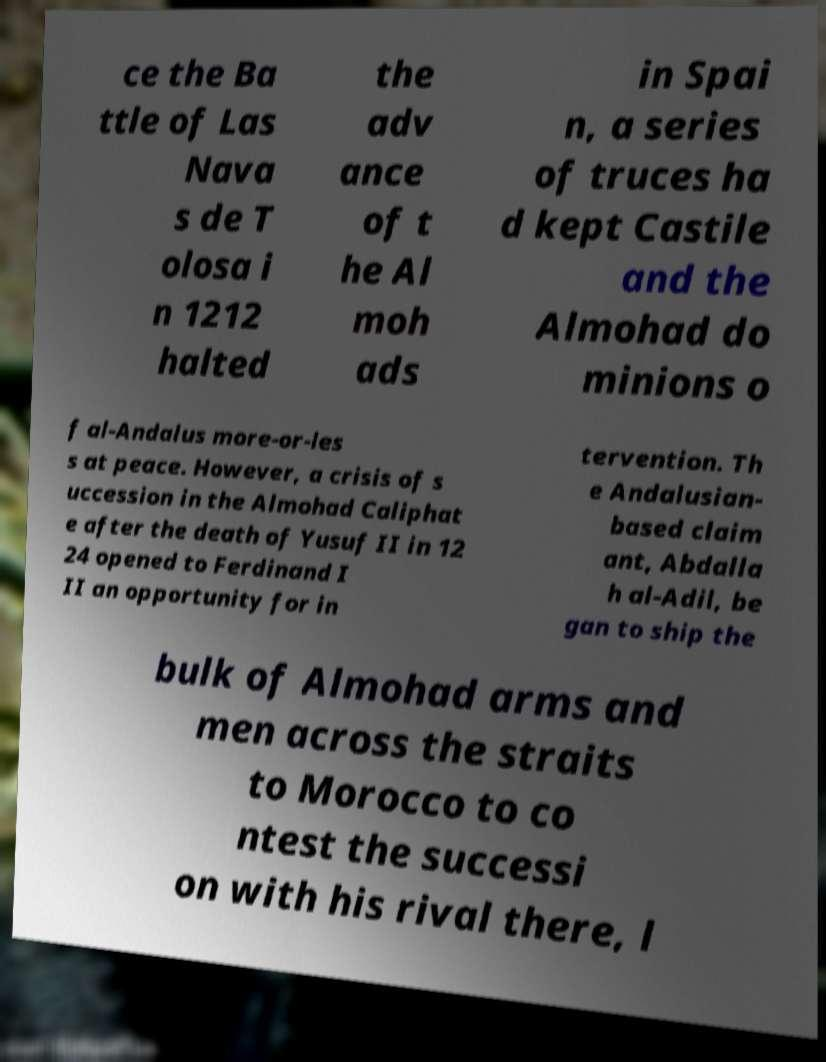Please read and relay the text visible in this image. What does it say? ce the Ba ttle of Las Nava s de T olosa i n 1212 halted the adv ance of t he Al moh ads in Spai n, a series of truces ha d kept Castile and the Almohad do minions o f al-Andalus more-or-les s at peace. However, a crisis of s uccession in the Almohad Caliphat e after the death of Yusuf II in 12 24 opened to Ferdinand I II an opportunity for in tervention. Th e Andalusian- based claim ant, Abdalla h al-Adil, be gan to ship the bulk of Almohad arms and men across the straits to Morocco to co ntest the successi on with his rival there, l 